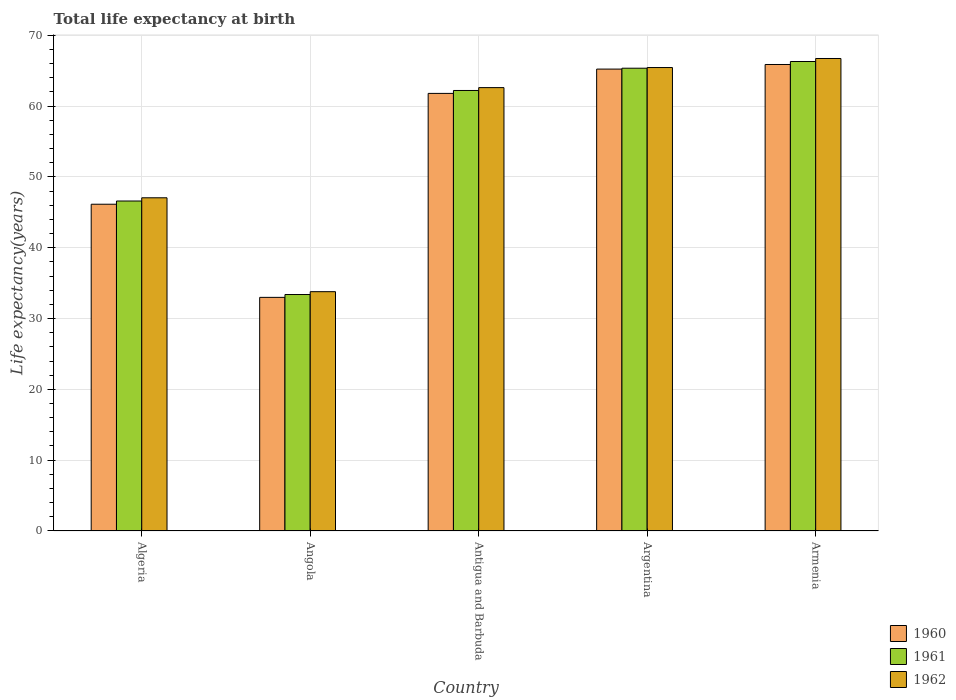How many groups of bars are there?
Your response must be concise. 5. Are the number of bars on each tick of the X-axis equal?
Provide a succinct answer. Yes. How many bars are there on the 5th tick from the left?
Keep it short and to the point. 3. How many bars are there on the 5th tick from the right?
Ensure brevity in your answer.  3. What is the label of the 5th group of bars from the left?
Make the answer very short. Armenia. In how many cases, is the number of bars for a given country not equal to the number of legend labels?
Your response must be concise. 0. What is the life expectancy at birth in in 1960 in Argentina?
Your answer should be very brief. 65.22. Across all countries, what is the maximum life expectancy at birth in in 1962?
Give a very brief answer. 66.71. Across all countries, what is the minimum life expectancy at birth in in 1962?
Make the answer very short. 33.79. In which country was the life expectancy at birth in in 1960 maximum?
Offer a very short reply. Armenia. In which country was the life expectancy at birth in in 1962 minimum?
Your answer should be very brief. Angola. What is the total life expectancy at birth in in 1960 in the graph?
Offer a very short reply. 271.98. What is the difference between the life expectancy at birth in in 1961 in Algeria and that in Angola?
Your answer should be very brief. 13.2. What is the difference between the life expectancy at birth in in 1961 in Armenia and the life expectancy at birth in in 1960 in Angola?
Ensure brevity in your answer.  33.3. What is the average life expectancy at birth in in 1962 per country?
Offer a very short reply. 55.11. What is the difference between the life expectancy at birth in of/in 1961 and life expectancy at birth in of/in 1960 in Antigua and Barbuda?
Your answer should be compact. 0.41. In how many countries, is the life expectancy at birth in in 1960 greater than 14 years?
Your answer should be very brief. 5. What is the ratio of the life expectancy at birth in in 1962 in Algeria to that in Antigua and Barbuda?
Make the answer very short. 0.75. Is the life expectancy at birth in in 1961 in Argentina less than that in Armenia?
Your answer should be compact. Yes. What is the difference between the highest and the second highest life expectancy at birth in in 1960?
Provide a succinct answer. -0.65. What is the difference between the highest and the lowest life expectancy at birth in in 1962?
Make the answer very short. 32.92. What does the 2nd bar from the left in Angola represents?
Offer a terse response. 1961. What does the 3rd bar from the right in Argentina represents?
Offer a terse response. 1960. How many bars are there?
Offer a very short reply. 15. What is the difference between two consecutive major ticks on the Y-axis?
Give a very brief answer. 10. Are the values on the major ticks of Y-axis written in scientific E-notation?
Make the answer very short. No. Does the graph contain grids?
Give a very brief answer. Yes. What is the title of the graph?
Your answer should be compact. Total life expectancy at birth. Does "1962" appear as one of the legend labels in the graph?
Your answer should be very brief. Yes. What is the label or title of the Y-axis?
Provide a succinct answer. Life expectancy(years). What is the Life expectancy(years) in 1960 in Algeria?
Make the answer very short. 46.14. What is the Life expectancy(years) of 1961 in Algeria?
Ensure brevity in your answer.  46.59. What is the Life expectancy(years) in 1962 in Algeria?
Your answer should be compact. 47.05. What is the Life expectancy(years) in 1960 in Angola?
Your answer should be compact. 32.98. What is the Life expectancy(years) of 1961 in Angola?
Give a very brief answer. 33.39. What is the Life expectancy(years) in 1962 in Angola?
Provide a short and direct response. 33.79. What is the Life expectancy(years) of 1960 in Antigua and Barbuda?
Your answer should be very brief. 61.78. What is the Life expectancy(years) of 1961 in Antigua and Barbuda?
Ensure brevity in your answer.  62.2. What is the Life expectancy(years) in 1962 in Antigua and Barbuda?
Your answer should be very brief. 62.6. What is the Life expectancy(years) in 1960 in Argentina?
Offer a terse response. 65.22. What is the Life expectancy(years) of 1961 in Argentina?
Provide a short and direct response. 65.34. What is the Life expectancy(years) of 1962 in Argentina?
Make the answer very short. 65.43. What is the Life expectancy(years) in 1960 in Armenia?
Offer a very short reply. 65.86. What is the Life expectancy(years) in 1961 in Armenia?
Offer a terse response. 66.28. What is the Life expectancy(years) in 1962 in Armenia?
Your response must be concise. 66.71. Across all countries, what is the maximum Life expectancy(years) of 1960?
Keep it short and to the point. 65.86. Across all countries, what is the maximum Life expectancy(years) in 1961?
Ensure brevity in your answer.  66.28. Across all countries, what is the maximum Life expectancy(years) in 1962?
Make the answer very short. 66.71. Across all countries, what is the minimum Life expectancy(years) of 1960?
Your response must be concise. 32.98. Across all countries, what is the minimum Life expectancy(years) of 1961?
Give a very brief answer. 33.39. Across all countries, what is the minimum Life expectancy(years) in 1962?
Offer a terse response. 33.79. What is the total Life expectancy(years) in 1960 in the graph?
Your answer should be compact. 271.98. What is the total Life expectancy(years) in 1961 in the graph?
Provide a short and direct response. 273.79. What is the total Life expectancy(years) in 1962 in the graph?
Provide a short and direct response. 275.57. What is the difference between the Life expectancy(years) in 1960 in Algeria and that in Angola?
Your answer should be very brief. 13.15. What is the difference between the Life expectancy(years) of 1961 in Algeria and that in Angola?
Your response must be concise. 13.2. What is the difference between the Life expectancy(years) in 1962 in Algeria and that in Angola?
Make the answer very short. 13.26. What is the difference between the Life expectancy(years) in 1960 in Algeria and that in Antigua and Barbuda?
Your answer should be compact. -15.65. What is the difference between the Life expectancy(years) in 1961 in Algeria and that in Antigua and Barbuda?
Give a very brief answer. -15.61. What is the difference between the Life expectancy(years) in 1962 in Algeria and that in Antigua and Barbuda?
Ensure brevity in your answer.  -15.55. What is the difference between the Life expectancy(years) in 1960 in Algeria and that in Argentina?
Provide a succinct answer. -19.08. What is the difference between the Life expectancy(years) in 1961 in Algeria and that in Argentina?
Provide a succinct answer. -18.75. What is the difference between the Life expectancy(years) of 1962 in Algeria and that in Argentina?
Provide a succinct answer. -18.39. What is the difference between the Life expectancy(years) of 1960 in Algeria and that in Armenia?
Your answer should be compact. -19.73. What is the difference between the Life expectancy(years) in 1961 in Algeria and that in Armenia?
Provide a succinct answer. -19.69. What is the difference between the Life expectancy(years) in 1962 in Algeria and that in Armenia?
Make the answer very short. -19.66. What is the difference between the Life expectancy(years) in 1960 in Angola and that in Antigua and Barbuda?
Your answer should be compact. -28.8. What is the difference between the Life expectancy(years) in 1961 in Angola and that in Antigua and Barbuda?
Your answer should be compact. -28.81. What is the difference between the Life expectancy(years) in 1962 in Angola and that in Antigua and Barbuda?
Offer a very short reply. -28.81. What is the difference between the Life expectancy(years) of 1960 in Angola and that in Argentina?
Provide a succinct answer. -32.23. What is the difference between the Life expectancy(years) in 1961 in Angola and that in Argentina?
Ensure brevity in your answer.  -31.95. What is the difference between the Life expectancy(years) of 1962 in Angola and that in Argentina?
Keep it short and to the point. -31.64. What is the difference between the Life expectancy(years) of 1960 in Angola and that in Armenia?
Ensure brevity in your answer.  -32.88. What is the difference between the Life expectancy(years) in 1961 in Angola and that in Armenia?
Offer a terse response. -32.9. What is the difference between the Life expectancy(years) of 1962 in Angola and that in Armenia?
Ensure brevity in your answer.  -32.92. What is the difference between the Life expectancy(years) of 1960 in Antigua and Barbuda and that in Argentina?
Your answer should be compact. -3.43. What is the difference between the Life expectancy(years) of 1961 in Antigua and Barbuda and that in Argentina?
Ensure brevity in your answer.  -3.14. What is the difference between the Life expectancy(years) in 1962 in Antigua and Barbuda and that in Argentina?
Give a very brief answer. -2.83. What is the difference between the Life expectancy(years) in 1960 in Antigua and Barbuda and that in Armenia?
Your answer should be compact. -4.08. What is the difference between the Life expectancy(years) of 1961 in Antigua and Barbuda and that in Armenia?
Offer a very short reply. -4.09. What is the difference between the Life expectancy(years) of 1962 in Antigua and Barbuda and that in Armenia?
Offer a terse response. -4.11. What is the difference between the Life expectancy(years) in 1960 in Argentina and that in Armenia?
Give a very brief answer. -0.65. What is the difference between the Life expectancy(years) in 1961 in Argentina and that in Armenia?
Your response must be concise. -0.95. What is the difference between the Life expectancy(years) in 1962 in Argentina and that in Armenia?
Your response must be concise. -1.28. What is the difference between the Life expectancy(years) in 1960 in Algeria and the Life expectancy(years) in 1961 in Angola?
Your response must be concise. 12.75. What is the difference between the Life expectancy(years) of 1960 in Algeria and the Life expectancy(years) of 1962 in Angola?
Your answer should be very brief. 12.35. What is the difference between the Life expectancy(years) of 1961 in Algeria and the Life expectancy(years) of 1962 in Angola?
Offer a very short reply. 12.8. What is the difference between the Life expectancy(years) of 1960 in Algeria and the Life expectancy(years) of 1961 in Antigua and Barbuda?
Offer a terse response. -16.06. What is the difference between the Life expectancy(years) of 1960 in Algeria and the Life expectancy(years) of 1962 in Antigua and Barbuda?
Provide a succinct answer. -16.46. What is the difference between the Life expectancy(years) of 1961 in Algeria and the Life expectancy(years) of 1962 in Antigua and Barbuda?
Offer a very short reply. -16.01. What is the difference between the Life expectancy(years) in 1960 in Algeria and the Life expectancy(years) in 1961 in Argentina?
Your answer should be very brief. -19.2. What is the difference between the Life expectancy(years) in 1960 in Algeria and the Life expectancy(years) in 1962 in Argentina?
Your answer should be very brief. -19.3. What is the difference between the Life expectancy(years) of 1961 in Algeria and the Life expectancy(years) of 1962 in Argentina?
Your answer should be compact. -18.84. What is the difference between the Life expectancy(years) of 1960 in Algeria and the Life expectancy(years) of 1961 in Armenia?
Your answer should be compact. -20.15. What is the difference between the Life expectancy(years) of 1960 in Algeria and the Life expectancy(years) of 1962 in Armenia?
Provide a succinct answer. -20.57. What is the difference between the Life expectancy(years) in 1961 in Algeria and the Life expectancy(years) in 1962 in Armenia?
Offer a very short reply. -20.12. What is the difference between the Life expectancy(years) in 1960 in Angola and the Life expectancy(years) in 1961 in Antigua and Barbuda?
Your response must be concise. -29.21. What is the difference between the Life expectancy(years) in 1960 in Angola and the Life expectancy(years) in 1962 in Antigua and Barbuda?
Offer a terse response. -29.61. What is the difference between the Life expectancy(years) of 1961 in Angola and the Life expectancy(years) of 1962 in Antigua and Barbuda?
Your answer should be compact. -29.21. What is the difference between the Life expectancy(years) in 1960 in Angola and the Life expectancy(years) in 1961 in Argentina?
Your answer should be compact. -32.35. What is the difference between the Life expectancy(years) of 1960 in Angola and the Life expectancy(years) of 1962 in Argentina?
Offer a terse response. -32.45. What is the difference between the Life expectancy(years) of 1961 in Angola and the Life expectancy(years) of 1962 in Argentina?
Give a very brief answer. -32.05. What is the difference between the Life expectancy(years) in 1960 in Angola and the Life expectancy(years) in 1961 in Armenia?
Your answer should be compact. -33.3. What is the difference between the Life expectancy(years) in 1960 in Angola and the Life expectancy(years) in 1962 in Armenia?
Your answer should be very brief. -33.73. What is the difference between the Life expectancy(years) in 1961 in Angola and the Life expectancy(years) in 1962 in Armenia?
Your answer should be compact. -33.32. What is the difference between the Life expectancy(years) in 1960 in Antigua and Barbuda and the Life expectancy(years) in 1961 in Argentina?
Offer a terse response. -3.56. What is the difference between the Life expectancy(years) of 1960 in Antigua and Barbuda and the Life expectancy(years) of 1962 in Argentina?
Your answer should be very brief. -3.65. What is the difference between the Life expectancy(years) of 1961 in Antigua and Barbuda and the Life expectancy(years) of 1962 in Argentina?
Offer a terse response. -3.24. What is the difference between the Life expectancy(years) in 1960 in Antigua and Barbuda and the Life expectancy(years) in 1961 in Armenia?
Your answer should be compact. -4.5. What is the difference between the Life expectancy(years) in 1960 in Antigua and Barbuda and the Life expectancy(years) in 1962 in Armenia?
Offer a terse response. -4.93. What is the difference between the Life expectancy(years) of 1961 in Antigua and Barbuda and the Life expectancy(years) of 1962 in Armenia?
Your answer should be compact. -4.51. What is the difference between the Life expectancy(years) of 1960 in Argentina and the Life expectancy(years) of 1961 in Armenia?
Your response must be concise. -1.07. What is the difference between the Life expectancy(years) in 1960 in Argentina and the Life expectancy(years) in 1962 in Armenia?
Offer a very short reply. -1.49. What is the difference between the Life expectancy(years) of 1961 in Argentina and the Life expectancy(years) of 1962 in Armenia?
Your answer should be compact. -1.37. What is the average Life expectancy(years) in 1960 per country?
Provide a short and direct response. 54.4. What is the average Life expectancy(years) of 1961 per country?
Offer a terse response. 54.76. What is the average Life expectancy(years) of 1962 per country?
Offer a terse response. 55.11. What is the difference between the Life expectancy(years) of 1960 and Life expectancy(years) of 1961 in Algeria?
Your answer should be compact. -0.46. What is the difference between the Life expectancy(years) of 1960 and Life expectancy(years) of 1962 in Algeria?
Your response must be concise. -0.91. What is the difference between the Life expectancy(years) in 1961 and Life expectancy(years) in 1962 in Algeria?
Offer a terse response. -0.45. What is the difference between the Life expectancy(years) in 1960 and Life expectancy(years) in 1961 in Angola?
Offer a very short reply. -0.4. What is the difference between the Life expectancy(years) of 1960 and Life expectancy(years) of 1962 in Angola?
Offer a very short reply. -0.8. What is the difference between the Life expectancy(years) of 1961 and Life expectancy(years) of 1962 in Angola?
Your answer should be compact. -0.4. What is the difference between the Life expectancy(years) in 1960 and Life expectancy(years) in 1961 in Antigua and Barbuda?
Your response must be concise. -0.41. What is the difference between the Life expectancy(years) in 1960 and Life expectancy(years) in 1962 in Antigua and Barbuda?
Your response must be concise. -0.82. What is the difference between the Life expectancy(years) in 1961 and Life expectancy(years) in 1962 in Antigua and Barbuda?
Keep it short and to the point. -0.4. What is the difference between the Life expectancy(years) in 1960 and Life expectancy(years) in 1961 in Argentina?
Your answer should be compact. -0.12. What is the difference between the Life expectancy(years) in 1960 and Life expectancy(years) in 1962 in Argentina?
Provide a succinct answer. -0.22. What is the difference between the Life expectancy(years) in 1961 and Life expectancy(years) in 1962 in Argentina?
Offer a very short reply. -0.09. What is the difference between the Life expectancy(years) of 1960 and Life expectancy(years) of 1961 in Armenia?
Provide a succinct answer. -0.42. What is the difference between the Life expectancy(years) in 1960 and Life expectancy(years) in 1962 in Armenia?
Your response must be concise. -0.85. What is the difference between the Life expectancy(years) in 1961 and Life expectancy(years) in 1962 in Armenia?
Offer a very short reply. -0.43. What is the ratio of the Life expectancy(years) of 1960 in Algeria to that in Angola?
Make the answer very short. 1.4. What is the ratio of the Life expectancy(years) in 1961 in Algeria to that in Angola?
Offer a terse response. 1.4. What is the ratio of the Life expectancy(years) in 1962 in Algeria to that in Angola?
Keep it short and to the point. 1.39. What is the ratio of the Life expectancy(years) in 1960 in Algeria to that in Antigua and Barbuda?
Your response must be concise. 0.75. What is the ratio of the Life expectancy(years) in 1961 in Algeria to that in Antigua and Barbuda?
Make the answer very short. 0.75. What is the ratio of the Life expectancy(years) in 1962 in Algeria to that in Antigua and Barbuda?
Provide a succinct answer. 0.75. What is the ratio of the Life expectancy(years) in 1960 in Algeria to that in Argentina?
Ensure brevity in your answer.  0.71. What is the ratio of the Life expectancy(years) in 1961 in Algeria to that in Argentina?
Keep it short and to the point. 0.71. What is the ratio of the Life expectancy(years) in 1962 in Algeria to that in Argentina?
Provide a short and direct response. 0.72. What is the ratio of the Life expectancy(years) of 1960 in Algeria to that in Armenia?
Ensure brevity in your answer.  0.7. What is the ratio of the Life expectancy(years) of 1961 in Algeria to that in Armenia?
Make the answer very short. 0.7. What is the ratio of the Life expectancy(years) in 1962 in Algeria to that in Armenia?
Make the answer very short. 0.71. What is the ratio of the Life expectancy(years) of 1960 in Angola to that in Antigua and Barbuda?
Your response must be concise. 0.53. What is the ratio of the Life expectancy(years) in 1961 in Angola to that in Antigua and Barbuda?
Your response must be concise. 0.54. What is the ratio of the Life expectancy(years) in 1962 in Angola to that in Antigua and Barbuda?
Provide a short and direct response. 0.54. What is the ratio of the Life expectancy(years) of 1960 in Angola to that in Argentina?
Make the answer very short. 0.51. What is the ratio of the Life expectancy(years) in 1961 in Angola to that in Argentina?
Make the answer very short. 0.51. What is the ratio of the Life expectancy(years) in 1962 in Angola to that in Argentina?
Keep it short and to the point. 0.52. What is the ratio of the Life expectancy(years) of 1960 in Angola to that in Armenia?
Your response must be concise. 0.5. What is the ratio of the Life expectancy(years) in 1961 in Angola to that in Armenia?
Ensure brevity in your answer.  0.5. What is the ratio of the Life expectancy(years) in 1962 in Angola to that in Armenia?
Offer a very short reply. 0.51. What is the ratio of the Life expectancy(years) in 1961 in Antigua and Barbuda to that in Argentina?
Provide a succinct answer. 0.95. What is the ratio of the Life expectancy(years) in 1962 in Antigua and Barbuda to that in Argentina?
Your answer should be compact. 0.96. What is the ratio of the Life expectancy(years) in 1960 in Antigua and Barbuda to that in Armenia?
Give a very brief answer. 0.94. What is the ratio of the Life expectancy(years) of 1961 in Antigua and Barbuda to that in Armenia?
Ensure brevity in your answer.  0.94. What is the ratio of the Life expectancy(years) in 1962 in Antigua and Barbuda to that in Armenia?
Your answer should be very brief. 0.94. What is the ratio of the Life expectancy(years) in 1960 in Argentina to that in Armenia?
Your answer should be very brief. 0.99. What is the ratio of the Life expectancy(years) in 1961 in Argentina to that in Armenia?
Offer a very short reply. 0.99. What is the ratio of the Life expectancy(years) in 1962 in Argentina to that in Armenia?
Provide a short and direct response. 0.98. What is the difference between the highest and the second highest Life expectancy(years) of 1960?
Ensure brevity in your answer.  0.65. What is the difference between the highest and the second highest Life expectancy(years) of 1961?
Make the answer very short. 0.95. What is the difference between the highest and the second highest Life expectancy(years) in 1962?
Ensure brevity in your answer.  1.28. What is the difference between the highest and the lowest Life expectancy(years) of 1960?
Your answer should be very brief. 32.88. What is the difference between the highest and the lowest Life expectancy(years) of 1961?
Your response must be concise. 32.9. What is the difference between the highest and the lowest Life expectancy(years) of 1962?
Offer a terse response. 32.92. 